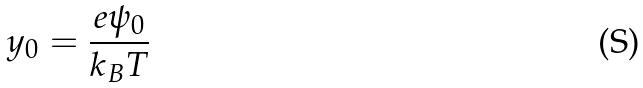Convert formula to latex. <formula><loc_0><loc_0><loc_500><loc_500>y _ { 0 } = \frac { e \psi _ { 0 } } { k _ { B } T }</formula> 